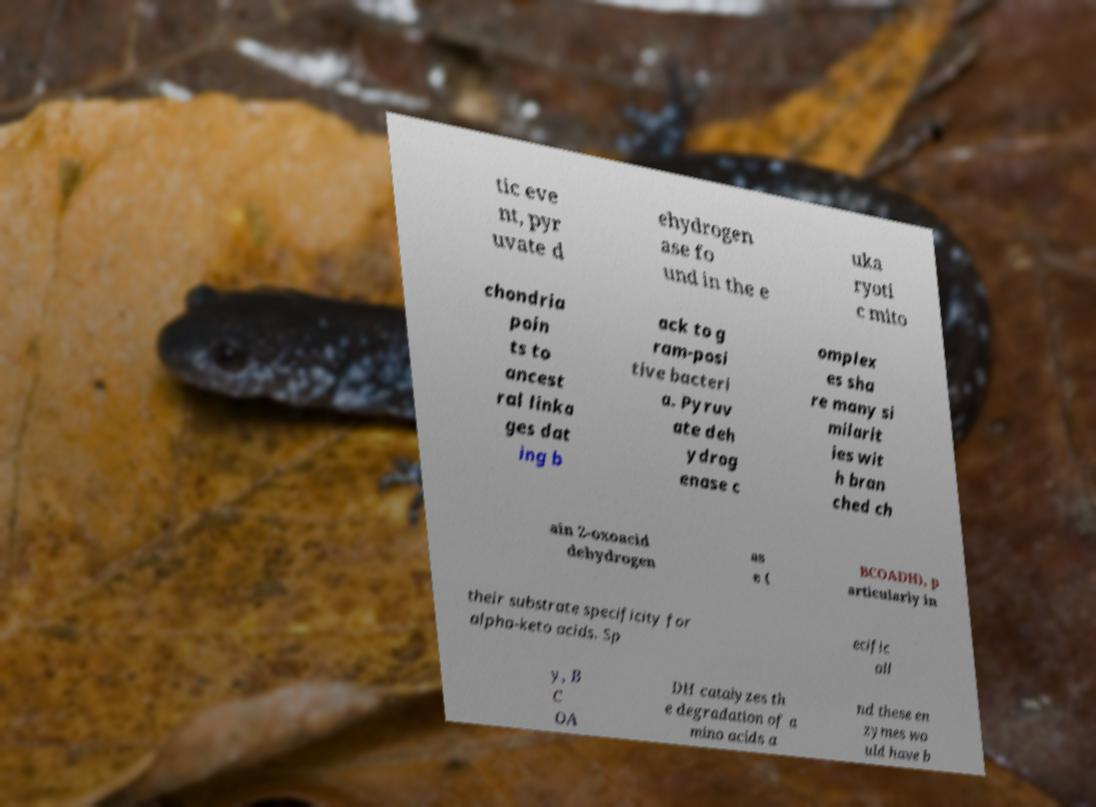Could you assist in decoding the text presented in this image and type it out clearly? tic eve nt, pyr uvate d ehydrogen ase fo und in the e uka ryoti c mito chondria poin ts to ancest ral linka ges dat ing b ack to g ram-posi tive bacteri a. Pyruv ate deh ydrog enase c omplex es sha re many si milarit ies wit h bran ched ch ain 2-oxoacid dehydrogen as e ( BCOADH), p articularly in their substrate specificity for alpha-keto acids. Sp ecific all y, B C OA DH catalyzes th e degradation of a mino acids a nd these en zymes wo uld have b 